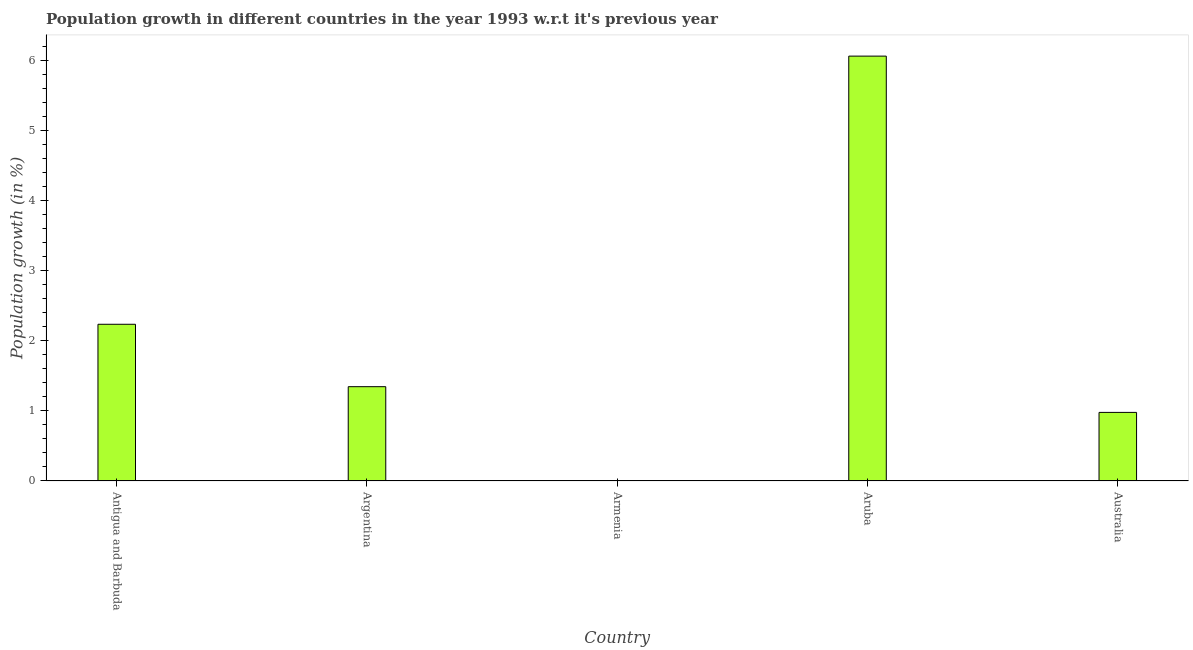Does the graph contain grids?
Offer a very short reply. No. What is the title of the graph?
Give a very brief answer. Population growth in different countries in the year 1993 w.r.t it's previous year. What is the label or title of the Y-axis?
Your response must be concise. Population growth (in %). What is the population growth in Antigua and Barbuda?
Make the answer very short. 2.24. Across all countries, what is the maximum population growth?
Provide a succinct answer. 6.06. In which country was the population growth maximum?
Provide a short and direct response. Aruba. What is the sum of the population growth?
Make the answer very short. 10.62. What is the difference between the population growth in Antigua and Barbuda and Aruba?
Give a very brief answer. -3.83. What is the average population growth per country?
Make the answer very short. 2.12. What is the median population growth?
Your response must be concise. 1.35. In how many countries, is the population growth greater than 3.8 %?
Your response must be concise. 1. What is the ratio of the population growth in Aruba to that in Australia?
Provide a succinct answer. 6.19. What is the difference between the highest and the second highest population growth?
Provide a succinct answer. 3.83. Is the sum of the population growth in Antigua and Barbuda and Aruba greater than the maximum population growth across all countries?
Your response must be concise. Yes. What is the difference between the highest and the lowest population growth?
Keep it short and to the point. 6.06. In how many countries, is the population growth greater than the average population growth taken over all countries?
Give a very brief answer. 2. How many bars are there?
Provide a succinct answer. 4. Are all the bars in the graph horizontal?
Provide a short and direct response. No. Are the values on the major ticks of Y-axis written in scientific E-notation?
Provide a short and direct response. No. What is the Population growth (in %) in Antigua and Barbuda?
Give a very brief answer. 2.24. What is the Population growth (in %) of Argentina?
Provide a short and direct response. 1.35. What is the Population growth (in %) in Aruba?
Give a very brief answer. 6.06. What is the Population growth (in %) in Australia?
Ensure brevity in your answer.  0.98. What is the difference between the Population growth (in %) in Antigua and Barbuda and Argentina?
Ensure brevity in your answer.  0.89. What is the difference between the Population growth (in %) in Antigua and Barbuda and Aruba?
Offer a terse response. -3.82. What is the difference between the Population growth (in %) in Antigua and Barbuda and Australia?
Your answer should be compact. 1.26. What is the difference between the Population growth (in %) in Argentina and Aruba?
Give a very brief answer. -4.72. What is the difference between the Population growth (in %) in Argentina and Australia?
Your answer should be very brief. 0.37. What is the difference between the Population growth (in %) in Aruba and Australia?
Provide a short and direct response. 5.08. What is the ratio of the Population growth (in %) in Antigua and Barbuda to that in Argentina?
Your response must be concise. 1.66. What is the ratio of the Population growth (in %) in Antigua and Barbuda to that in Aruba?
Provide a succinct answer. 0.37. What is the ratio of the Population growth (in %) in Antigua and Barbuda to that in Australia?
Ensure brevity in your answer.  2.29. What is the ratio of the Population growth (in %) in Argentina to that in Aruba?
Your response must be concise. 0.22. What is the ratio of the Population growth (in %) in Argentina to that in Australia?
Your response must be concise. 1.38. What is the ratio of the Population growth (in %) in Aruba to that in Australia?
Provide a succinct answer. 6.19. 